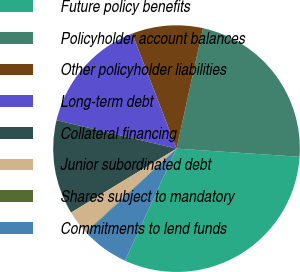Convert chart to OTSL. <chart><loc_0><loc_0><loc_500><loc_500><pie_chart><fcel>Future policy benefits<fcel>Policyholder account balances<fcel>Other policyholder liabilities<fcel>Long-term debt<fcel>Collateral financing<fcel>Junior subordinated debt<fcel>Shares subject to mandatory<fcel>Commitments to lend funds<nl><fcel>30.8%<fcel>22.61%<fcel>9.3%<fcel>15.44%<fcel>12.37%<fcel>3.16%<fcel>0.08%<fcel>6.23%<nl></chart> 